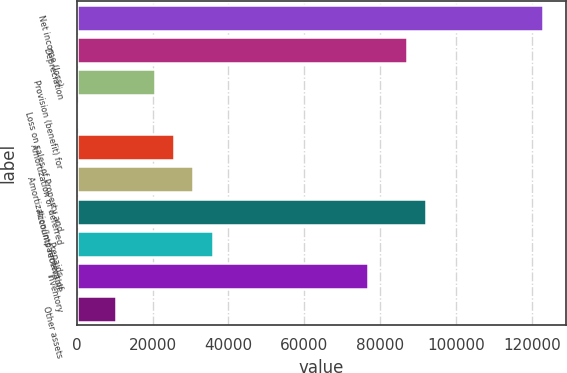Convert chart to OTSL. <chart><loc_0><loc_0><loc_500><loc_500><bar_chart><fcel>Net income (loss)<fcel>Depreciation<fcel>Provision (benefit) for<fcel>Loss on sales of Property and<fcel>Amortization of deferred<fcel>Amortization/Impairment of<fcel>Accounts receivable<fcel>Prepaids<fcel>Inventory<fcel>Other assets<nl><fcel>122816<fcel>87014.2<fcel>20524.4<fcel>66<fcel>25639<fcel>30753.6<fcel>92128.8<fcel>35868.2<fcel>76785<fcel>10295.2<nl></chart> 